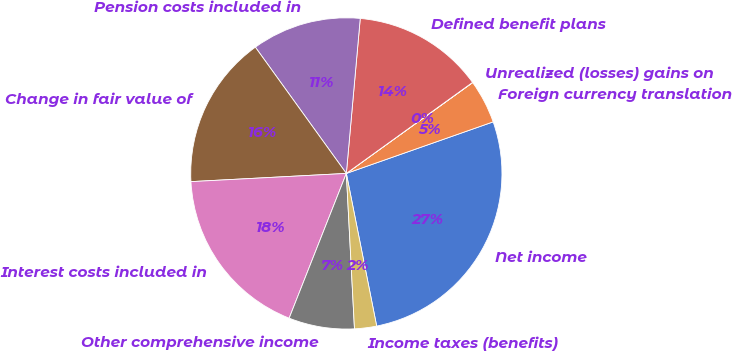Convert chart to OTSL. <chart><loc_0><loc_0><loc_500><loc_500><pie_chart><fcel>Net income<fcel>Foreign currency translation<fcel>Unrealized (losses) gains on<fcel>Defined benefit plans<fcel>Pension costs included in<fcel>Change in fair value of<fcel>Interest costs included in<fcel>Other comprehensive income<fcel>Income taxes (benefits)<nl><fcel>27.25%<fcel>4.55%<fcel>0.02%<fcel>13.63%<fcel>11.36%<fcel>15.9%<fcel>18.17%<fcel>6.82%<fcel>2.29%<nl></chart> 